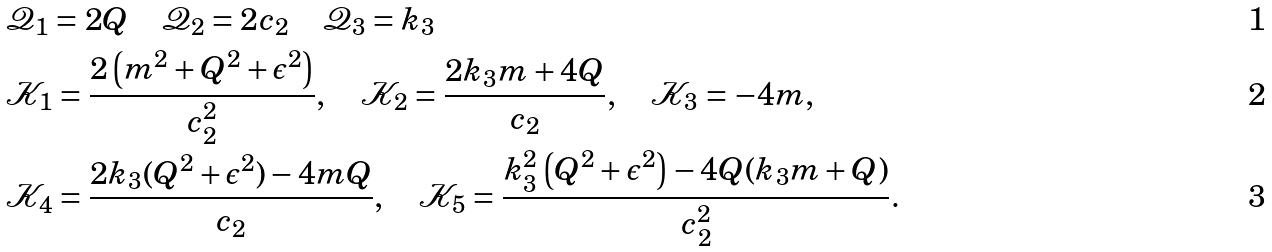Convert formula to latex. <formula><loc_0><loc_0><loc_500><loc_500>& \mathcal { Q } _ { 1 } = 2 Q \quad \mathcal { Q } _ { 2 } = 2 c _ { 2 } \quad \mathcal { Q } _ { 3 } = k _ { 3 } \\ & \mathcal { K } _ { 1 } = \frac { 2 \left ( m ^ { 2 } + Q ^ { 2 } + \epsilon ^ { 2 } \right ) } { c _ { 2 } ^ { 2 } } , \quad \mathcal { K } _ { 2 } = \frac { 2 k _ { 3 } m + 4 Q } { c _ { 2 } } , \quad \mathcal { K } _ { 3 } = - 4 m , \\ & \mathcal { K } _ { 4 } = \frac { 2 k _ { 3 } ( Q ^ { 2 } + \epsilon ^ { 2 } ) - 4 m Q } { c _ { 2 } } , \quad \mathcal { K } _ { 5 } = \frac { k _ { 3 } ^ { 2 } \left ( Q ^ { 2 } + \epsilon ^ { 2 } \right ) - 4 Q ( k _ { 3 } m + Q ) } { c _ { 2 } ^ { 2 } } .</formula> 